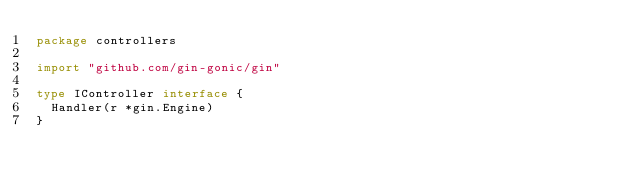Convert code to text. <code><loc_0><loc_0><loc_500><loc_500><_Go_>package controllers

import "github.com/gin-gonic/gin"

type IController interface {
	Handler(r *gin.Engine)
}
</code> 